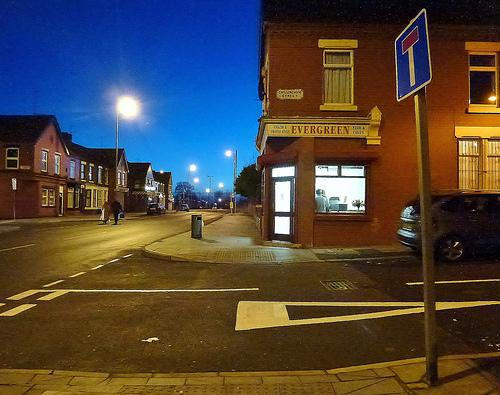What is the main function of street lamps and are they turned on in the image? The main function of street lamps is to provide illumination and they are turned on in the image. What type of vehicle is parked on the side of the street, and describe its position. A mini van is parked on the side of the road, and it is positioned far off. What color is the sky in the image, and what is its condition? The sky is a clear dark blue color. Can you count the total number of windows mentioned in the image description? There are ten windows mentioned in the image description. How many people are mentioned in the image description? There are two people mentioned in the image description. Briefly describe the scene on the street. The scene shows a street with buildings, cars parked on the side, people, sidewalk, street signs, trashcans, and street lamps. What are the objects or settings interacting with each other in the image? The sidewalk is crashing with a handicap accessible ramp, and cars are parked along the street next to buildings and sidewalks. What is the color and shape of the sign on the building, and what is it made of? The sign on the building is white with red letters, and it is rectangular in shape. Identify two types of lines present on the street and their respective colors. There are white lines and yellow lines present on the street. Is there a big red trashcan on the sidewalk? No, it's not mentioned in the image. Is there a T crossing street sign in the image? If yes, describe it. Yes, there is a T crossing street sign of size 82x82 pixels. What type of sky is shown in the image? A clear dark blue sky Design a poster using the elements from the image provided. A poster with a city street theme, featuring parked cars, signs, street lights, and buildings under a clear dark blue sky. Describe the trashcan on the sidewalk in this image. The trashcan is silver with a size of 18x18 pixels. Do all the windows in the image have blue curtains? The instruction is misleading because only one window is mentioned having a curtain, and the color of the curtain is not specified. The other windows do not mention curtains at all. Is there a white pole holding up the blue and white sign? This instruction is misleading because the pole holding up the blue and white sign is described as gray, not white. Examine the image and tell me the size of the window near the doorway. The window near the doorway has a size of 60x60 pixels. Translate the text on the white sign with red letters on the building. Unable to translate, as there is no actual text provided. Identify an event occurring on this street scene. No specific event detected. Detect an ongoing event in the image, if any. No specific event identified. What color are the triangular street lines in the image? White Identify any text written on the blue and white sign. Unable to identify, as there is no actual text provided. In a narrative style, describe the scene depicted in the image. On a lively city street, cars are parked along the sidewalk, while buildings and various signs create a bustling atmosphere. The sun has set, leaving behind a clear dark blue sky that promises a calm evening ahead. Which object is accessible to differently-abled people in the image? Handicap accessible ramp What activity is taking place in the corner store? People are seen inside the corner store. Write a caption describing the scene depicted in the image. A city street with parked cars, sidewalk, buildings, and various signs and street lights under a clear dark blue sky. Which object in the image helps to illuminate the space at night? Street lamp Observe the image and state whether there is any garbage can present. Yes, there is a gray and brown garbage can with a size of 24x24 pixels. Explain the content of the diagram shown in the image. No diagram present in the image. Is the sign on the building green with yellow letters? The instruction is misleading because the sign on the building is described as white with red letters, not green with yellow letters. 